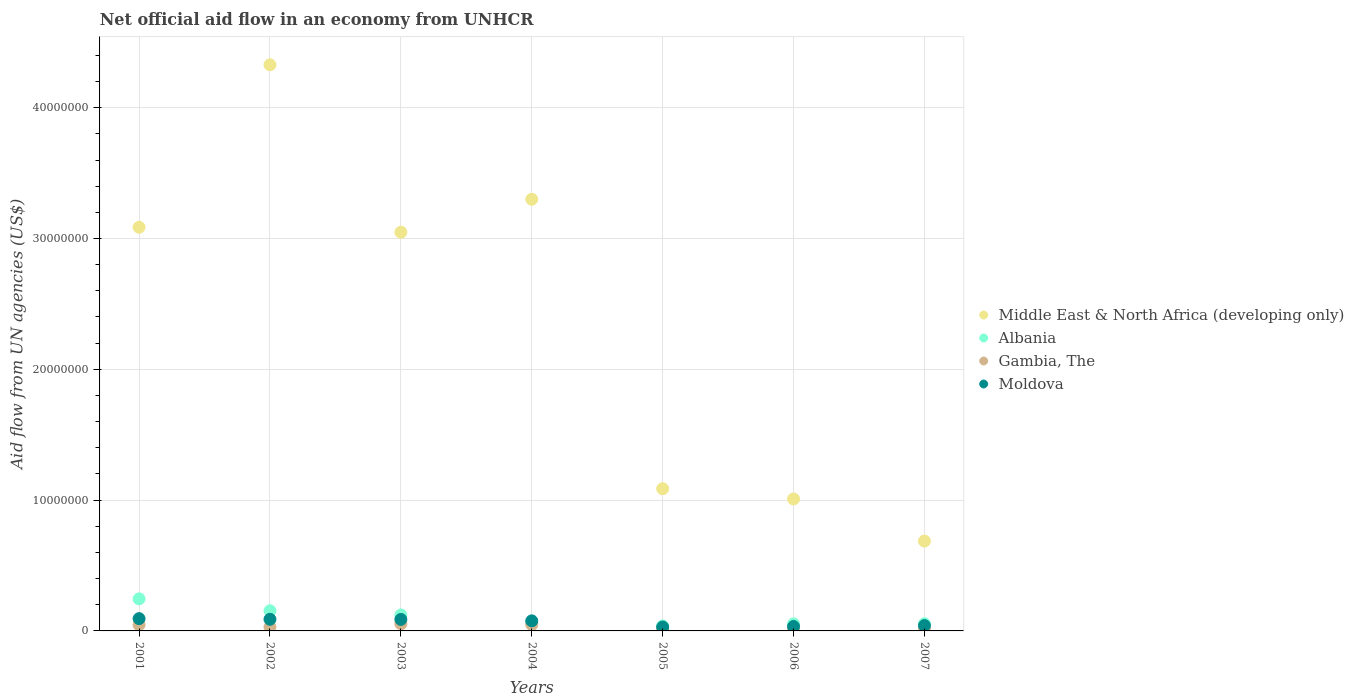How many different coloured dotlines are there?
Your response must be concise. 4. Is the number of dotlines equal to the number of legend labels?
Ensure brevity in your answer.  Yes. Across all years, what is the maximum net official aid flow in Albania?
Your answer should be very brief. 2.45e+06. Across all years, what is the minimum net official aid flow in Moldova?
Your answer should be compact. 3.00e+05. In which year was the net official aid flow in Albania maximum?
Your answer should be very brief. 2001. What is the total net official aid flow in Middle East & North Africa (developing only) in the graph?
Your response must be concise. 1.65e+08. What is the difference between the net official aid flow in Albania in 2006 and that in 2007?
Your response must be concise. -10000. What is the difference between the net official aid flow in Gambia, The in 2005 and the net official aid flow in Middle East & North Africa (developing only) in 2007?
Your answer should be compact. -6.69e+06. What is the average net official aid flow in Middle East & North Africa (developing only) per year?
Give a very brief answer. 2.36e+07. In how many years, is the net official aid flow in Gambia, The greater than 14000000 US$?
Your answer should be compact. 0. What is the ratio of the net official aid flow in Moldova in 2005 to that in 2007?
Your answer should be compact. 0.73. Is the difference between the net official aid flow in Albania in 2003 and 2004 greater than the difference between the net official aid flow in Gambia, The in 2003 and 2004?
Keep it short and to the point. Yes. What is the difference between the highest and the second highest net official aid flow in Gambia, The?
Provide a succinct answer. 6.00e+04. What is the difference between the highest and the lowest net official aid flow in Albania?
Your answer should be very brief. 2.07e+06. In how many years, is the net official aid flow in Albania greater than the average net official aid flow in Albania taken over all years?
Make the answer very short. 3. Is it the case that in every year, the sum of the net official aid flow in Gambia, The and net official aid flow in Moldova  is greater than the net official aid flow in Middle East & North Africa (developing only)?
Offer a very short reply. No. Does the net official aid flow in Middle East & North Africa (developing only) monotonically increase over the years?
Keep it short and to the point. No. Is the net official aid flow in Albania strictly less than the net official aid flow in Gambia, The over the years?
Offer a terse response. No. How many dotlines are there?
Your answer should be compact. 4. How many years are there in the graph?
Give a very brief answer. 7. What is the difference between two consecutive major ticks on the Y-axis?
Offer a terse response. 1.00e+07. Are the values on the major ticks of Y-axis written in scientific E-notation?
Ensure brevity in your answer.  No. Does the graph contain grids?
Ensure brevity in your answer.  Yes. How many legend labels are there?
Your response must be concise. 4. How are the legend labels stacked?
Your response must be concise. Vertical. What is the title of the graph?
Make the answer very short. Net official aid flow in an economy from UNHCR. What is the label or title of the Y-axis?
Your response must be concise. Aid flow from UN agencies (US$). What is the Aid flow from UN agencies (US$) of Middle East & North Africa (developing only) in 2001?
Your answer should be compact. 3.09e+07. What is the Aid flow from UN agencies (US$) in Albania in 2001?
Give a very brief answer. 2.45e+06. What is the Aid flow from UN agencies (US$) in Moldova in 2001?
Your answer should be very brief. 9.40e+05. What is the Aid flow from UN agencies (US$) of Middle East & North Africa (developing only) in 2002?
Offer a terse response. 4.33e+07. What is the Aid flow from UN agencies (US$) in Albania in 2002?
Your response must be concise. 1.54e+06. What is the Aid flow from UN agencies (US$) of Gambia, The in 2002?
Offer a very short reply. 3.00e+05. What is the Aid flow from UN agencies (US$) in Moldova in 2002?
Provide a short and direct response. 8.90e+05. What is the Aid flow from UN agencies (US$) in Middle East & North Africa (developing only) in 2003?
Your answer should be compact. 3.05e+07. What is the Aid flow from UN agencies (US$) of Albania in 2003?
Your answer should be compact. 1.22e+06. What is the Aid flow from UN agencies (US$) in Gambia, The in 2003?
Ensure brevity in your answer.  5.40e+05. What is the Aid flow from UN agencies (US$) in Moldova in 2003?
Provide a short and direct response. 8.80e+05. What is the Aid flow from UN agencies (US$) of Middle East & North Africa (developing only) in 2004?
Give a very brief answer. 3.30e+07. What is the Aid flow from UN agencies (US$) of Albania in 2004?
Ensure brevity in your answer.  6.20e+05. What is the Aid flow from UN agencies (US$) of Moldova in 2004?
Make the answer very short. 7.70e+05. What is the Aid flow from UN agencies (US$) in Middle East & North Africa (developing only) in 2005?
Your response must be concise. 1.09e+07. What is the Aid flow from UN agencies (US$) of Albania in 2005?
Offer a very short reply. 3.80e+05. What is the Aid flow from UN agencies (US$) in Gambia, The in 2005?
Offer a terse response. 1.80e+05. What is the Aid flow from UN agencies (US$) in Middle East & North Africa (developing only) in 2006?
Your answer should be compact. 1.01e+07. What is the Aid flow from UN agencies (US$) of Albania in 2006?
Provide a succinct answer. 5.40e+05. What is the Aid flow from UN agencies (US$) of Middle East & North Africa (developing only) in 2007?
Your answer should be compact. 6.87e+06. What is the Aid flow from UN agencies (US$) in Albania in 2007?
Make the answer very short. 5.50e+05. What is the Aid flow from UN agencies (US$) of Gambia, The in 2007?
Ensure brevity in your answer.  1.20e+05. Across all years, what is the maximum Aid flow from UN agencies (US$) of Middle East & North Africa (developing only)?
Offer a very short reply. 4.33e+07. Across all years, what is the maximum Aid flow from UN agencies (US$) in Albania?
Keep it short and to the point. 2.45e+06. Across all years, what is the maximum Aid flow from UN agencies (US$) of Gambia, The?
Keep it short and to the point. 5.40e+05. Across all years, what is the maximum Aid flow from UN agencies (US$) of Moldova?
Your answer should be compact. 9.40e+05. Across all years, what is the minimum Aid flow from UN agencies (US$) in Middle East & North Africa (developing only)?
Offer a very short reply. 6.87e+06. What is the total Aid flow from UN agencies (US$) of Middle East & North Africa (developing only) in the graph?
Keep it short and to the point. 1.65e+08. What is the total Aid flow from UN agencies (US$) in Albania in the graph?
Offer a terse response. 7.30e+06. What is the total Aid flow from UN agencies (US$) in Gambia, The in the graph?
Your response must be concise. 2.20e+06. What is the total Aid flow from UN agencies (US$) of Moldova in the graph?
Your answer should be very brief. 4.53e+06. What is the difference between the Aid flow from UN agencies (US$) of Middle East & North Africa (developing only) in 2001 and that in 2002?
Your answer should be compact. -1.24e+07. What is the difference between the Aid flow from UN agencies (US$) in Albania in 2001 and that in 2002?
Your answer should be very brief. 9.10e+05. What is the difference between the Aid flow from UN agencies (US$) in Gambia, The in 2001 and that in 2002?
Offer a terse response. 1.70e+05. What is the difference between the Aid flow from UN agencies (US$) of Middle East & North Africa (developing only) in 2001 and that in 2003?
Offer a terse response. 3.80e+05. What is the difference between the Aid flow from UN agencies (US$) of Albania in 2001 and that in 2003?
Ensure brevity in your answer.  1.23e+06. What is the difference between the Aid flow from UN agencies (US$) in Moldova in 2001 and that in 2003?
Offer a terse response. 6.00e+04. What is the difference between the Aid flow from UN agencies (US$) of Middle East & North Africa (developing only) in 2001 and that in 2004?
Your answer should be compact. -2.14e+06. What is the difference between the Aid flow from UN agencies (US$) in Albania in 2001 and that in 2004?
Keep it short and to the point. 1.83e+06. What is the difference between the Aid flow from UN agencies (US$) in Middle East & North Africa (developing only) in 2001 and that in 2005?
Your response must be concise. 2.00e+07. What is the difference between the Aid flow from UN agencies (US$) in Albania in 2001 and that in 2005?
Provide a short and direct response. 2.07e+06. What is the difference between the Aid flow from UN agencies (US$) in Gambia, The in 2001 and that in 2005?
Provide a short and direct response. 2.90e+05. What is the difference between the Aid flow from UN agencies (US$) of Moldova in 2001 and that in 2005?
Provide a short and direct response. 6.40e+05. What is the difference between the Aid flow from UN agencies (US$) of Middle East & North Africa (developing only) in 2001 and that in 2006?
Make the answer very short. 2.08e+07. What is the difference between the Aid flow from UN agencies (US$) of Albania in 2001 and that in 2006?
Provide a succinct answer. 1.91e+06. What is the difference between the Aid flow from UN agencies (US$) in Gambia, The in 2001 and that in 2006?
Make the answer very short. 3.60e+05. What is the difference between the Aid flow from UN agencies (US$) of Moldova in 2001 and that in 2006?
Your answer should be compact. 6.00e+05. What is the difference between the Aid flow from UN agencies (US$) in Middle East & North Africa (developing only) in 2001 and that in 2007?
Offer a very short reply. 2.40e+07. What is the difference between the Aid flow from UN agencies (US$) of Albania in 2001 and that in 2007?
Keep it short and to the point. 1.90e+06. What is the difference between the Aid flow from UN agencies (US$) in Moldova in 2001 and that in 2007?
Your answer should be very brief. 5.30e+05. What is the difference between the Aid flow from UN agencies (US$) in Middle East & North Africa (developing only) in 2002 and that in 2003?
Your response must be concise. 1.28e+07. What is the difference between the Aid flow from UN agencies (US$) in Middle East & North Africa (developing only) in 2002 and that in 2004?
Offer a terse response. 1.03e+07. What is the difference between the Aid flow from UN agencies (US$) of Albania in 2002 and that in 2004?
Your response must be concise. 9.20e+05. What is the difference between the Aid flow from UN agencies (US$) in Middle East & North Africa (developing only) in 2002 and that in 2005?
Ensure brevity in your answer.  3.24e+07. What is the difference between the Aid flow from UN agencies (US$) in Albania in 2002 and that in 2005?
Offer a very short reply. 1.16e+06. What is the difference between the Aid flow from UN agencies (US$) in Moldova in 2002 and that in 2005?
Your response must be concise. 5.90e+05. What is the difference between the Aid flow from UN agencies (US$) in Middle East & North Africa (developing only) in 2002 and that in 2006?
Make the answer very short. 3.32e+07. What is the difference between the Aid flow from UN agencies (US$) in Gambia, The in 2002 and that in 2006?
Provide a succinct answer. 1.90e+05. What is the difference between the Aid flow from UN agencies (US$) of Middle East & North Africa (developing only) in 2002 and that in 2007?
Your answer should be very brief. 3.64e+07. What is the difference between the Aid flow from UN agencies (US$) of Albania in 2002 and that in 2007?
Your response must be concise. 9.90e+05. What is the difference between the Aid flow from UN agencies (US$) in Gambia, The in 2002 and that in 2007?
Your answer should be very brief. 1.80e+05. What is the difference between the Aid flow from UN agencies (US$) in Middle East & North Africa (developing only) in 2003 and that in 2004?
Keep it short and to the point. -2.52e+06. What is the difference between the Aid flow from UN agencies (US$) of Gambia, The in 2003 and that in 2004?
Provide a succinct answer. 6.00e+04. What is the difference between the Aid flow from UN agencies (US$) in Middle East & North Africa (developing only) in 2003 and that in 2005?
Offer a very short reply. 1.96e+07. What is the difference between the Aid flow from UN agencies (US$) in Albania in 2003 and that in 2005?
Give a very brief answer. 8.40e+05. What is the difference between the Aid flow from UN agencies (US$) in Gambia, The in 2003 and that in 2005?
Offer a terse response. 3.60e+05. What is the difference between the Aid flow from UN agencies (US$) in Moldova in 2003 and that in 2005?
Offer a terse response. 5.80e+05. What is the difference between the Aid flow from UN agencies (US$) of Middle East & North Africa (developing only) in 2003 and that in 2006?
Ensure brevity in your answer.  2.04e+07. What is the difference between the Aid flow from UN agencies (US$) in Albania in 2003 and that in 2006?
Provide a short and direct response. 6.80e+05. What is the difference between the Aid flow from UN agencies (US$) in Moldova in 2003 and that in 2006?
Keep it short and to the point. 5.40e+05. What is the difference between the Aid flow from UN agencies (US$) in Middle East & North Africa (developing only) in 2003 and that in 2007?
Your answer should be very brief. 2.36e+07. What is the difference between the Aid flow from UN agencies (US$) in Albania in 2003 and that in 2007?
Your response must be concise. 6.70e+05. What is the difference between the Aid flow from UN agencies (US$) of Middle East & North Africa (developing only) in 2004 and that in 2005?
Give a very brief answer. 2.21e+07. What is the difference between the Aid flow from UN agencies (US$) in Gambia, The in 2004 and that in 2005?
Offer a very short reply. 3.00e+05. What is the difference between the Aid flow from UN agencies (US$) of Middle East & North Africa (developing only) in 2004 and that in 2006?
Offer a terse response. 2.29e+07. What is the difference between the Aid flow from UN agencies (US$) of Gambia, The in 2004 and that in 2006?
Your answer should be very brief. 3.70e+05. What is the difference between the Aid flow from UN agencies (US$) of Middle East & North Africa (developing only) in 2004 and that in 2007?
Make the answer very short. 2.61e+07. What is the difference between the Aid flow from UN agencies (US$) in Albania in 2004 and that in 2007?
Make the answer very short. 7.00e+04. What is the difference between the Aid flow from UN agencies (US$) in Moldova in 2004 and that in 2007?
Your response must be concise. 3.60e+05. What is the difference between the Aid flow from UN agencies (US$) in Middle East & North Africa (developing only) in 2005 and that in 2006?
Offer a very short reply. 7.80e+05. What is the difference between the Aid flow from UN agencies (US$) in Albania in 2005 and that in 2006?
Your response must be concise. -1.60e+05. What is the difference between the Aid flow from UN agencies (US$) in Gambia, The in 2005 and that in 2006?
Make the answer very short. 7.00e+04. What is the difference between the Aid flow from UN agencies (US$) in Moldova in 2005 and that in 2006?
Your answer should be very brief. -4.00e+04. What is the difference between the Aid flow from UN agencies (US$) in Middle East & North Africa (developing only) in 2005 and that in 2007?
Offer a terse response. 4.00e+06. What is the difference between the Aid flow from UN agencies (US$) in Albania in 2005 and that in 2007?
Give a very brief answer. -1.70e+05. What is the difference between the Aid flow from UN agencies (US$) of Middle East & North Africa (developing only) in 2006 and that in 2007?
Your answer should be very brief. 3.22e+06. What is the difference between the Aid flow from UN agencies (US$) in Albania in 2006 and that in 2007?
Keep it short and to the point. -10000. What is the difference between the Aid flow from UN agencies (US$) of Middle East & North Africa (developing only) in 2001 and the Aid flow from UN agencies (US$) of Albania in 2002?
Provide a short and direct response. 2.93e+07. What is the difference between the Aid flow from UN agencies (US$) of Middle East & North Africa (developing only) in 2001 and the Aid flow from UN agencies (US$) of Gambia, The in 2002?
Provide a short and direct response. 3.06e+07. What is the difference between the Aid flow from UN agencies (US$) in Middle East & North Africa (developing only) in 2001 and the Aid flow from UN agencies (US$) in Moldova in 2002?
Offer a very short reply. 3.00e+07. What is the difference between the Aid flow from UN agencies (US$) in Albania in 2001 and the Aid flow from UN agencies (US$) in Gambia, The in 2002?
Provide a succinct answer. 2.15e+06. What is the difference between the Aid flow from UN agencies (US$) of Albania in 2001 and the Aid flow from UN agencies (US$) of Moldova in 2002?
Make the answer very short. 1.56e+06. What is the difference between the Aid flow from UN agencies (US$) of Gambia, The in 2001 and the Aid flow from UN agencies (US$) of Moldova in 2002?
Your answer should be very brief. -4.20e+05. What is the difference between the Aid flow from UN agencies (US$) of Middle East & North Africa (developing only) in 2001 and the Aid flow from UN agencies (US$) of Albania in 2003?
Your response must be concise. 2.96e+07. What is the difference between the Aid flow from UN agencies (US$) of Middle East & North Africa (developing only) in 2001 and the Aid flow from UN agencies (US$) of Gambia, The in 2003?
Provide a short and direct response. 3.03e+07. What is the difference between the Aid flow from UN agencies (US$) of Middle East & North Africa (developing only) in 2001 and the Aid flow from UN agencies (US$) of Moldova in 2003?
Your answer should be very brief. 3.00e+07. What is the difference between the Aid flow from UN agencies (US$) in Albania in 2001 and the Aid flow from UN agencies (US$) in Gambia, The in 2003?
Make the answer very short. 1.91e+06. What is the difference between the Aid flow from UN agencies (US$) in Albania in 2001 and the Aid flow from UN agencies (US$) in Moldova in 2003?
Offer a terse response. 1.57e+06. What is the difference between the Aid flow from UN agencies (US$) of Gambia, The in 2001 and the Aid flow from UN agencies (US$) of Moldova in 2003?
Ensure brevity in your answer.  -4.10e+05. What is the difference between the Aid flow from UN agencies (US$) of Middle East & North Africa (developing only) in 2001 and the Aid flow from UN agencies (US$) of Albania in 2004?
Ensure brevity in your answer.  3.02e+07. What is the difference between the Aid flow from UN agencies (US$) of Middle East & North Africa (developing only) in 2001 and the Aid flow from UN agencies (US$) of Gambia, The in 2004?
Provide a short and direct response. 3.04e+07. What is the difference between the Aid flow from UN agencies (US$) of Middle East & North Africa (developing only) in 2001 and the Aid flow from UN agencies (US$) of Moldova in 2004?
Offer a terse response. 3.01e+07. What is the difference between the Aid flow from UN agencies (US$) of Albania in 2001 and the Aid flow from UN agencies (US$) of Gambia, The in 2004?
Make the answer very short. 1.97e+06. What is the difference between the Aid flow from UN agencies (US$) in Albania in 2001 and the Aid flow from UN agencies (US$) in Moldova in 2004?
Your answer should be compact. 1.68e+06. What is the difference between the Aid flow from UN agencies (US$) in Gambia, The in 2001 and the Aid flow from UN agencies (US$) in Moldova in 2004?
Your response must be concise. -3.00e+05. What is the difference between the Aid flow from UN agencies (US$) of Middle East & North Africa (developing only) in 2001 and the Aid flow from UN agencies (US$) of Albania in 2005?
Offer a very short reply. 3.05e+07. What is the difference between the Aid flow from UN agencies (US$) in Middle East & North Africa (developing only) in 2001 and the Aid flow from UN agencies (US$) in Gambia, The in 2005?
Keep it short and to the point. 3.07e+07. What is the difference between the Aid flow from UN agencies (US$) of Middle East & North Africa (developing only) in 2001 and the Aid flow from UN agencies (US$) of Moldova in 2005?
Offer a terse response. 3.06e+07. What is the difference between the Aid flow from UN agencies (US$) in Albania in 2001 and the Aid flow from UN agencies (US$) in Gambia, The in 2005?
Keep it short and to the point. 2.27e+06. What is the difference between the Aid flow from UN agencies (US$) of Albania in 2001 and the Aid flow from UN agencies (US$) of Moldova in 2005?
Your answer should be compact. 2.15e+06. What is the difference between the Aid flow from UN agencies (US$) in Middle East & North Africa (developing only) in 2001 and the Aid flow from UN agencies (US$) in Albania in 2006?
Offer a very short reply. 3.03e+07. What is the difference between the Aid flow from UN agencies (US$) in Middle East & North Africa (developing only) in 2001 and the Aid flow from UN agencies (US$) in Gambia, The in 2006?
Provide a succinct answer. 3.08e+07. What is the difference between the Aid flow from UN agencies (US$) in Middle East & North Africa (developing only) in 2001 and the Aid flow from UN agencies (US$) in Moldova in 2006?
Your answer should be very brief. 3.05e+07. What is the difference between the Aid flow from UN agencies (US$) of Albania in 2001 and the Aid flow from UN agencies (US$) of Gambia, The in 2006?
Make the answer very short. 2.34e+06. What is the difference between the Aid flow from UN agencies (US$) of Albania in 2001 and the Aid flow from UN agencies (US$) of Moldova in 2006?
Your response must be concise. 2.11e+06. What is the difference between the Aid flow from UN agencies (US$) in Middle East & North Africa (developing only) in 2001 and the Aid flow from UN agencies (US$) in Albania in 2007?
Give a very brief answer. 3.03e+07. What is the difference between the Aid flow from UN agencies (US$) of Middle East & North Africa (developing only) in 2001 and the Aid flow from UN agencies (US$) of Gambia, The in 2007?
Offer a terse response. 3.07e+07. What is the difference between the Aid flow from UN agencies (US$) in Middle East & North Africa (developing only) in 2001 and the Aid flow from UN agencies (US$) in Moldova in 2007?
Offer a terse response. 3.04e+07. What is the difference between the Aid flow from UN agencies (US$) in Albania in 2001 and the Aid flow from UN agencies (US$) in Gambia, The in 2007?
Offer a very short reply. 2.33e+06. What is the difference between the Aid flow from UN agencies (US$) of Albania in 2001 and the Aid flow from UN agencies (US$) of Moldova in 2007?
Make the answer very short. 2.04e+06. What is the difference between the Aid flow from UN agencies (US$) in Gambia, The in 2001 and the Aid flow from UN agencies (US$) in Moldova in 2007?
Keep it short and to the point. 6.00e+04. What is the difference between the Aid flow from UN agencies (US$) in Middle East & North Africa (developing only) in 2002 and the Aid flow from UN agencies (US$) in Albania in 2003?
Offer a terse response. 4.21e+07. What is the difference between the Aid flow from UN agencies (US$) in Middle East & North Africa (developing only) in 2002 and the Aid flow from UN agencies (US$) in Gambia, The in 2003?
Your answer should be compact. 4.27e+07. What is the difference between the Aid flow from UN agencies (US$) of Middle East & North Africa (developing only) in 2002 and the Aid flow from UN agencies (US$) of Moldova in 2003?
Ensure brevity in your answer.  4.24e+07. What is the difference between the Aid flow from UN agencies (US$) in Albania in 2002 and the Aid flow from UN agencies (US$) in Gambia, The in 2003?
Your answer should be compact. 1.00e+06. What is the difference between the Aid flow from UN agencies (US$) of Gambia, The in 2002 and the Aid flow from UN agencies (US$) of Moldova in 2003?
Offer a terse response. -5.80e+05. What is the difference between the Aid flow from UN agencies (US$) of Middle East & North Africa (developing only) in 2002 and the Aid flow from UN agencies (US$) of Albania in 2004?
Make the answer very short. 4.27e+07. What is the difference between the Aid flow from UN agencies (US$) in Middle East & North Africa (developing only) in 2002 and the Aid flow from UN agencies (US$) in Gambia, The in 2004?
Provide a succinct answer. 4.28e+07. What is the difference between the Aid flow from UN agencies (US$) of Middle East & North Africa (developing only) in 2002 and the Aid flow from UN agencies (US$) of Moldova in 2004?
Keep it short and to the point. 4.25e+07. What is the difference between the Aid flow from UN agencies (US$) of Albania in 2002 and the Aid flow from UN agencies (US$) of Gambia, The in 2004?
Your answer should be very brief. 1.06e+06. What is the difference between the Aid flow from UN agencies (US$) in Albania in 2002 and the Aid flow from UN agencies (US$) in Moldova in 2004?
Ensure brevity in your answer.  7.70e+05. What is the difference between the Aid flow from UN agencies (US$) of Gambia, The in 2002 and the Aid flow from UN agencies (US$) of Moldova in 2004?
Make the answer very short. -4.70e+05. What is the difference between the Aid flow from UN agencies (US$) of Middle East & North Africa (developing only) in 2002 and the Aid flow from UN agencies (US$) of Albania in 2005?
Your answer should be compact. 4.29e+07. What is the difference between the Aid flow from UN agencies (US$) of Middle East & North Africa (developing only) in 2002 and the Aid flow from UN agencies (US$) of Gambia, The in 2005?
Ensure brevity in your answer.  4.31e+07. What is the difference between the Aid flow from UN agencies (US$) of Middle East & North Africa (developing only) in 2002 and the Aid flow from UN agencies (US$) of Moldova in 2005?
Provide a succinct answer. 4.30e+07. What is the difference between the Aid flow from UN agencies (US$) of Albania in 2002 and the Aid flow from UN agencies (US$) of Gambia, The in 2005?
Your answer should be very brief. 1.36e+06. What is the difference between the Aid flow from UN agencies (US$) in Albania in 2002 and the Aid flow from UN agencies (US$) in Moldova in 2005?
Give a very brief answer. 1.24e+06. What is the difference between the Aid flow from UN agencies (US$) in Middle East & North Africa (developing only) in 2002 and the Aid flow from UN agencies (US$) in Albania in 2006?
Give a very brief answer. 4.27e+07. What is the difference between the Aid flow from UN agencies (US$) of Middle East & North Africa (developing only) in 2002 and the Aid flow from UN agencies (US$) of Gambia, The in 2006?
Give a very brief answer. 4.32e+07. What is the difference between the Aid flow from UN agencies (US$) of Middle East & North Africa (developing only) in 2002 and the Aid flow from UN agencies (US$) of Moldova in 2006?
Your answer should be compact. 4.29e+07. What is the difference between the Aid flow from UN agencies (US$) of Albania in 2002 and the Aid flow from UN agencies (US$) of Gambia, The in 2006?
Make the answer very short. 1.43e+06. What is the difference between the Aid flow from UN agencies (US$) of Albania in 2002 and the Aid flow from UN agencies (US$) of Moldova in 2006?
Your response must be concise. 1.20e+06. What is the difference between the Aid flow from UN agencies (US$) of Gambia, The in 2002 and the Aid flow from UN agencies (US$) of Moldova in 2006?
Ensure brevity in your answer.  -4.00e+04. What is the difference between the Aid flow from UN agencies (US$) in Middle East & North Africa (developing only) in 2002 and the Aid flow from UN agencies (US$) in Albania in 2007?
Your response must be concise. 4.27e+07. What is the difference between the Aid flow from UN agencies (US$) in Middle East & North Africa (developing only) in 2002 and the Aid flow from UN agencies (US$) in Gambia, The in 2007?
Make the answer very short. 4.32e+07. What is the difference between the Aid flow from UN agencies (US$) in Middle East & North Africa (developing only) in 2002 and the Aid flow from UN agencies (US$) in Moldova in 2007?
Offer a very short reply. 4.29e+07. What is the difference between the Aid flow from UN agencies (US$) in Albania in 2002 and the Aid flow from UN agencies (US$) in Gambia, The in 2007?
Keep it short and to the point. 1.42e+06. What is the difference between the Aid flow from UN agencies (US$) of Albania in 2002 and the Aid flow from UN agencies (US$) of Moldova in 2007?
Make the answer very short. 1.13e+06. What is the difference between the Aid flow from UN agencies (US$) in Middle East & North Africa (developing only) in 2003 and the Aid flow from UN agencies (US$) in Albania in 2004?
Offer a very short reply. 2.99e+07. What is the difference between the Aid flow from UN agencies (US$) in Middle East & North Africa (developing only) in 2003 and the Aid flow from UN agencies (US$) in Gambia, The in 2004?
Your response must be concise. 3.00e+07. What is the difference between the Aid flow from UN agencies (US$) in Middle East & North Africa (developing only) in 2003 and the Aid flow from UN agencies (US$) in Moldova in 2004?
Your answer should be very brief. 2.97e+07. What is the difference between the Aid flow from UN agencies (US$) in Albania in 2003 and the Aid flow from UN agencies (US$) in Gambia, The in 2004?
Your response must be concise. 7.40e+05. What is the difference between the Aid flow from UN agencies (US$) in Albania in 2003 and the Aid flow from UN agencies (US$) in Moldova in 2004?
Offer a very short reply. 4.50e+05. What is the difference between the Aid flow from UN agencies (US$) in Middle East & North Africa (developing only) in 2003 and the Aid flow from UN agencies (US$) in Albania in 2005?
Keep it short and to the point. 3.01e+07. What is the difference between the Aid flow from UN agencies (US$) of Middle East & North Africa (developing only) in 2003 and the Aid flow from UN agencies (US$) of Gambia, The in 2005?
Provide a short and direct response. 3.03e+07. What is the difference between the Aid flow from UN agencies (US$) in Middle East & North Africa (developing only) in 2003 and the Aid flow from UN agencies (US$) in Moldova in 2005?
Give a very brief answer. 3.02e+07. What is the difference between the Aid flow from UN agencies (US$) of Albania in 2003 and the Aid flow from UN agencies (US$) of Gambia, The in 2005?
Provide a short and direct response. 1.04e+06. What is the difference between the Aid flow from UN agencies (US$) in Albania in 2003 and the Aid flow from UN agencies (US$) in Moldova in 2005?
Offer a very short reply. 9.20e+05. What is the difference between the Aid flow from UN agencies (US$) of Middle East & North Africa (developing only) in 2003 and the Aid flow from UN agencies (US$) of Albania in 2006?
Provide a succinct answer. 2.99e+07. What is the difference between the Aid flow from UN agencies (US$) of Middle East & North Africa (developing only) in 2003 and the Aid flow from UN agencies (US$) of Gambia, The in 2006?
Keep it short and to the point. 3.04e+07. What is the difference between the Aid flow from UN agencies (US$) of Middle East & North Africa (developing only) in 2003 and the Aid flow from UN agencies (US$) of Moldova in 2006?
Your answer should be compact. 3.01e+07. What is the difference between the Aid flow from UN agencies (US$) in Albania in 2003 and the Aid flow from UN agencies (US$) in Gambia, The in 2006?
Keep it short and to the point. 1.11e+06. What is the difference between the Aid flow from UN agencies (US$) of Albania in 2003 and the Aid flow from UN agencies (US$) of Moldova in 2006?
Make the answer very short. 8.80e+05. What is the difference between the Aid flow from UN agencies (US$) in Gambia, The in 2003 and the Aid flow from UN agencies (US$) in Moldova in 2006?
Your response must be concise. 2.00e+05. What is the difference between the Aid flow from UN agencies (US$) of Middle East & North Africa (developing only) in 2003 and the Aid flow from UN agencies (US$) of Albania in 2007?
Ensure brevity in your answer.  2.99e+07. What is the difference between the Aid flow from UN agencies (US$) of Middle East & North Africa (developing only) in 2003 and the Aid flow from UN agencies (US$) of Gambia, The in 2007?
Provide a succinct answer. 3.04e+07. What is the difference between the Aid flow from UN agencies (US$) of Middle East & North Africa (developing only) in 2003 and the Aid flow from UN agencies (US$) of Moldova in 2007?
Offer a very short reply. 3.01e+07. What is the difference between the Aid flow from UN agencies (US$) in Albania in 2003 and the Aid flow from UN agencies (US$) in Gambia, The in 2007?
Offer a terse response. 1.10e+06. What is the difference between the Aid flow from UN agencies (US$) in Albania in 2003 and the Aid flow from UN agencies (US$) in Moldova in 2007?
Your response must be concise. 8.10e+05. What is the difference between the Aid flow from UN agencies (US$) in Middle East & North Africa (developing only) in 2004 and the Aid flow from UN agencies (US$) in Albania in 2005?
Make the answer very short. 3.26e+07. What is the difference between the Aid flow from UN agencies (US$) in Middle East & North Africa (developing only) in 2004 and the Aid flow from UN agencies (US$) in Gambia, The in 2005?
Make the answer very short. 3.28e+07. What is the difference between the Aid flow from UN agencies (US$) of Middle East & North Africa (developing only) in 2004 and the Aid flow from UN agencies (US$) of Moldova in 2005?
Offer a terse response. 3.27e+07. What is the difference between the Aid flow from UN agencies (US$) of Albania in 2004 and the Aid flow from UN agencies (US$) of Moldova in 2005?
Provide a succinct answer. 3.20e+05. What is the difference between the Aid flow from UN agencies (US$) of Gambia, The in 2004 and the Aid flow from UN agencies (US$) of Moldova in 2005?
Provide a succinct answer. 1.80e+05. What is the difference between the Aid flow from UN agencies (US$) of Middle East & North Africa (developing only) in 2004 and the Aid flow from UN agencies (US$) of Albania in 2006?
Your response must be concise. 3.25e+07. What is the difference between the Aid flow from UN agencies (US$) in Middle East & North Africa (developing only) in 2004 and the Aid flow from UN agencies (US$) in Gambia, The in 2006?
Make the answer very short. 3.29e+07. What is the difference between the Aid flow from UN agencies (US$) of Middle East & North Africa (developing only) in 2004 and the Aid flow from UN agencies (US$) of Moldova in 2006?
Your answer should be very brief. 3.27e+07. What is the difference between the Aid flow from UN agencies (US$) of Albania in 2004 and the Aid flow from UN agencies (US$) of Gambia, The in 2006?
Provide a succinct answer. 5.10e+05. What is the difference between the Aid flow from UN agencies (US$) in Albania in 2004 and the Aid flow from UN agencies (US$) in Moldova in 2006?
Give a very brief answer. 2.80e+05. What is the difference between the Aid flow from UN agencies (US$) of Middle East & North Africa (developing only) in 2004 and the Aid flow from UN agencies (US$) of Albania in 2007?
Provide a short and direct response. 3.24e+07. What is the difference between the Aid flow from UN agencies (US$) of Middle East & North Africa (developing only) in 2004 and the Aid flow from UN agencies (US$) of Gambia, The in 2007?
Offer a terse response. 3.29e+07. What is the difference between the Aid flow from UN agencies (US$) of Middle East & North Africa (developing only) in 2004 and the Aid flow from UN agencies (US$) of Moldova in 2007?
Give a very brief answer. 3.26e+07. What is the difference between the Aid flow from UN agencies (US$) of Albania in 2004 and the Aid flow from UN agencies (US$) of Gambia, The in 2007?
Ensure brevity in your answer.  5.00e+05. What is the difference between the Aid flow from UN agencies (US$) of Albania in 2004 and the Aid flow from UN agencies (US$) of Moldova in 2007?
Offer a terse response. 2.10e+05. What is the difference between the Aid flow from UN agencies (US$) of Middle East & North Africa (developing only) in 2005 and the Aid flow from UN agencies (US$) of Albania in 2006?
Offer a very short reply. 1.03e+07. What is the difference between the Aid flow from UN agencies (US$) in Middle East & North Africa (developing only) in 2005 and the Aid flow from UN agencies (US$) in Gambia, The in 2006?
Offer a terse response. 1.08e+07. What is the difference between the Aid flow from UN agencies (US$) of Middle East & North Africa (developing only) in 2005 and the Aid flow from UN agencies (US$) of Moldova in 2006?
Your response must be concise. 1.05e+07. What is the difference between the Aid flow from UN agencies (US$) of Middle East & North Africa (developing only) in 2005 and the Aid flow from UN agencies (US$) of Albania in 2007?
Give a very brief answer. 1.03e+07. What is the difference between the Aid flow from UN agencies (US$) in Middle East & North Africa (developing only) in 2005 and the Aid flow from UN agencies (US$) in Gambia, The in 2007?
Provide a succinct answer. 1.08e+07. What is the difference between the Aid flow from UN agencies (US$) in Middle East & North Africa (developing only) in 2005 and the Aid flow from UN agencies (US$) in Moldova in 2007?
Make the answer very short. 1.05e+07. What is the difference between the Aid flow from UN agencies (US$) in Albania in 2005 and the Aid flow from UN agencies (US$) in Gambia, The in 2007?
Your response must be concise. 2.60e+05. What is the difference between the Aid flow from UN agencies (US$) of Albania in 2005 and the Aid flow from UN agencies (US$) of Moldova in 2007?
Offer a very short reply. -3.00e+04. What is the difference between the Aid flow from UN agencies (US$) in Gambia, The in 2005 and the Aid flow from UN agencies (US$) in Moldova in 2007?
Make the answer very short. -2.30e+05. What is the difference between the Aid flow from UN agencies (US$) in Middle East & North Africa (developing only) in 2006 and the Aid flow from UN agencies (US$) in Albania in 2007?
Your answer should be compact. 9.54e+06. What is the difference between the Aid flow from UN agencies (US$) in Middle East & North Africa (developing only) in 2006 and the Aid flow from UN agencies (US$) in Gambia, The in 2007?
Ensure brevity in your answer.  9.97e+06. What is the difference between the Aid flow from UN agencies (US$) of Middle East & North Africa (developing only) in 2006 and the Aid flow from UN agencies (US$) of Moldova in 2007?
Your answer should be very brief. 9.68e+06. What is the difference between the Aid flow from UN agencies (US$) in Albania in 2006 and the Aid flow from UN agencies (US$) in Gambia, The in 2007?
Offer a very short reply. 4.20e+05. What is the average Aid flow from UN agencies (US$) in Middle East & North Africa (developing only) per year?
Keep it short and to the point. 2.36e+07. What is the average Aid flow from UN agencies (US$) in Albania per year?
Keep it short and to the point. 1.04e+06. What is the average Aid flow from UN agencies (US$) of Gambia, The per year?
Give a very brief answer. 3.14e+05. What is the average Aid flow from UN agencies (US$) of Moldova per year?
Provide a succinct answer. 6.47e+05. In the year 2001, what is the difference between the Aid flow from UN agencies (US$) in Middle East & North Africa (developing only) and Aid flow from UN agencies (US$) in Albania?
Provide a short and direct response. 2.84e+07. In the year 2001, what is the difference between the Aid flow from UN agencies (US$) in Middle East & North Africa (developing only) and Aid flow from UN agencies (US$) in Gambia, The?
Provide a short and direct response. 3.04e+07. In the year 2001, what is the difference between the Aid flow from UN agencies (US$) of Middle East & North Africa (developing only) and Aid flow from UN agencies (US$) of Moldova?
Your answer should be compact. 2.99e+07. In the year 2001, what is the difference between the Aid flow from UN agencies (US$) of Albania and Aid flow from UN agencies (US$) of Gambia, The?
Your answer should be very brief. 1.98e+06. In the year 2001, what is the difference between the Aid flow from UN agencies (US$) in Albania and Aid flow from UN agencies (US$) in Moldova?
Make the answer very short. 1.51e+06. In the year 2001, what is the difference between the Aid flow from UN agencies (US$) in Gambia, The and Aid flow from UN agencies (US$) in Moldova?
Ensure brevity in your answer.  -4.70e+05. In the year 2002, what is the difference between the Aid flow from UN agencies (US$) in Middle East & North Africa (developing only) and Aid flow from UN agencies (US$) in Albania?
Keep it short and to the point. 4.17e+07. In the year 2002, what is the difference between the Aid flow from UN agencies (US$) in Middle East & North Africa (developing only) and Aid flow from UN agencies (US$) in Gambia, The?
Your answer should be compact. 4.30e+07. In the year 2002, what is the difference between the Aid flow from UN agencies (US$) of Middle East & North Africa (developing only) and Aid flow from UN agencies (US$) of Moldova?
Ensure brevity in your answer.  4.24e+07. In the year 2002, what is the difference between the Aid flow from UN agencies (US$) in Albania and Aid flow from UN agencies (US$) in Gambia, The?
Make the answer very short. 1.24e+06. In the year 2002, what is the difference between the Aid flow from UN agencies (US$) of Albania and Aid flow from UN agencies (US$) of Moldova?
Your answer should be very brief. 6.50e+05. In the year 2002, what is the difference between the Aid flow from UN agencies (US$) in Gambia, The and Aid flow from UN agencies (US$) in Moldova?
Your answer should be compact. -5.90e+05. In the year 2003, what is the difference between the Aid flow from UN agencies (US$) of Middle East & North Africa (developing only) and Aid flow from UN agencies (US$) of Albania?
Offer a terse response. 2.93e+07. In the year 2003, what is the difference between the Aid flow from UN agencies (US$) in Middle East & North Africa (developing only) and Aid flow from UN agencies (US$) in Gambia, The?
Offer a terse response. 2.99e+07. In the year 2003, what is the difference between the Aid flow from UN agencies (US$) of Middle East & North Africa (developing only) and Aid flow from UN agencies (US$) of Moldova?
Keep it short and to the point. 2.96e+07. In the year 2003, what is the difference between the Aid flow from UN agencies (US$) in Albania and Aid flow from UN agencies (US$) in Gambia, The?
Provide a succinct answer. 6.80e+05. In the year 2003, what is the difference between the Aid flow from UN agencies (US$) in Gambia, The and Aid flow from UN agencies (US$) in Moldova?
Your answer should be very brief. -3.40e+05. In the year 2004, what is the difference between the Aid flow from UN agencies (US$) in Middle East & North Africa (developing only) and Aid flow from UN agencies (US$) in Albania?
Give a very brief answer. 3.24e+07. In the year 2004, what is the difference between the Aid flow from UN agencies (US$) of Middle East & North Africa (developing only) and Aid flow from UN agencies (US$) of Gambia, The?
Make the answer very short. 3.25e+07. In the year 2004, what is the difference between the Aid flow from UN agencies (US$) of Middle East & North Africa (developing only) and Aid flow from UN agencies (US$) of Moldova?
Give a very brief answer. 3.22e+07. In the year 2004, what is the difference between the Aid flow from UN agencies (US$) in Albania and Aid flow from UN agencies (US$) in Gambia, The?
Ensure brevity in your answer.  1.40e+05. In the year 2004, what is the difference between the Aid flow from UN agencies (US$) of Albania and Aid flow from UN agencies (US$) of Moldova?
Offer a terse response. -1.50e+05. In the year 2005, what is the difference between the Aid flow from UN agencies (US$) of Middle East & North Africa (developing only) and Aid flow from UN agencies (US$) of Albania?
Ensure brevity in your answer.  1.05e+07. In the year 2005, what is the difference between the Aid flow from UN agencies (US$) of Middle East & North Africa (developing only) and Aid flow from UN agencies (US$) of Gambia, The?
Provide a short and direct response. 1.07e+07. In the year 2005, what is the difference between the Aid flow from UN agencies (US$) of Middle East & North Africa (developing only) and Aid flow from UN agencies (US$) of Moldova?
Provide a short and direct response. 1.06e+07. In the year 2005, what is the difference between the Aid flow from UN agencies (US$) in Albania and Aid flow from UN agencies (US$) in Moldova?
Provide a short and direct response. 8.00e+04. In the year 2006, what is the difference between the Aid flow from UN agencies (US$) of Middle East & North Africa (developing only) and Aid flow from UN agencies (US$) of Albania?
Provide a succinct answer. 9.55e+06. In the year 2006, what is the difference between the Aid flow from UN agencies (US$) of Middle East & North Africa (developing only) and Aid flow from UN agencies (US$) of Gambia, The?
Your answer should be very brief. 9.98e+06. In the year 2006, what is the difference between the Aid flow from UN agencies (US$) of Middle East & North Africa (developing only) and Aid flow from UN agencies (US$) of Moldova?
Offer a terse response. 9.75e+06. In the year 2006, what is the difference between the Aid flow from UN agencies (US$) of Albania and Aid flow from UN agencies (US$) of Gambia, The?
Ensure brevity in your answer.  4.30e+05. In the year 2006, what is the difference between the Aid flow from UN agencies (US$) in Gambia, The and Aid flow from UN agencies (US$) in Moldova?
Your response must be concise. -2.30e+05. In the year 2007, what is the difference between the Aid flow from UN agencies (US$) in Middle East & North Africa (developing only) and Aid flow from UN agencies (US$) in Albania?
Your answer should be compact. 6.32e+06. In the year 2007, what is the difference between the Aid flow from UN agencies (US$) of Middle East & North Africa (developing only) and Aid flow from UN agencies (US$) of Gambia, The?
Your answer should be compact. 6.75e+06. In the year 2007, what is the difference between the Aid flow from UN agencies (US$) in Middle East & North Africa (developing only) and Aid flow from UN agencies (US$) in Moldova?
Your answer should be compact. 6.46e+06. In the year 2007, what is the difference between the Aid flow from UN agencies (US$) of Gambia, The and Aid flow from UN agencies (US$) of Moldova?
Provide a short and direct response. -2.90e+05. What is the ratio of the Aid flow from UN agencies (US$) of Middle East & North Africa (developing only) in 2001 to that in 2002?
Give a very brief answer. 0.71. What is the ratio of the Aid flow from UN agencies (US$) in Albania in 2001 to that in 2002?
Your answer should be compact. 1.59. What is the ratio of the Aid flow from UN agencies (US$) of Gambia, The in 2001 to that in 2002?
Provide a succinct answer. 1.57. What is the ratio of the Aid flow from UN agencies (US$) in Moldova in 2001 to that in 2002?
Ensure brevity in your answer.  1.06. What is the ratio of the Aid flow from UN agencies (US$) in Middle East & North Africa (developing only) in 2001 to that in 2003?
Give a very brief answer. 1.01. What is the ratio of the Aid flow from UN agencies (US$) of Albania in 2001 to that in 2003?
Your answer should be compact. 2.01. What is the ratio of the Aid flow from UN agencies (US$) in Gambia, The in 2001 to that in 2003?
Provide a short and direct response. 0.87. What is the ratio of the Aid flow from UN agencies (US$) of Moldova in 2001 to that in 2003?
Offer a very short reply. 1.07. What is the ratio of the Aid flow from UN agencies (US$) of Middle East & North Africa (developing only) in 2001 to that in 2004?
Make the answer very short. 0.94. What is the ratio of the Aid flow from UN agencies (US$) of Albania in 2001 to that in 2004?
Provide a succinct answer. 3.95. What is the ratio of the Aid flow from UN agencies (US$) of Gambia, The in 2001 to that in 2004?
Ensure brevity in your answer.  0.98. What is the ratio of the Aid flow from UN agencies (US$) of Moldova in 2001 to that in 2004?
Keep it short and to the point. 1.22. What is the ratio of the Aid flow from UN agencies (US$) of Middle East & North Africa (developing only) in 2001 to that in 2005?
Offer a terse response. 2.84. What is the ratio of the Aid flow from UN agencies (US$) of Albania in 2001 to that in 2005?
Your response must be concise. 6.45. What is the ratio of the Aid flow from UN agencies (US$) of Gambia, The in 2001 to that in 2005?
Your response must be concise. 2.61. What is the ratio of the Aid flow from UN agencies (US$) of Moldova in 2001 to that in 2005?
Your response must be concise. 3.13. What is the ratio of the Aid flow from UN agencies (US$) of Middle East & North Africa (developing only) in 2001 to that in 2006?
Offer a very short reply. 3.06. What is the ratio of the Aid flow from UN agencies (US$) in Albania in 2001 to that in 2006?
Your response must be concise. 4.54. What is the ratio of the Aid flow from UN agencies (US$) in Gambia, The in 2001 to that in 2006?
Ensure brevity in your answer.  4.27. What is the ratio of the Aid flow from UN agencies (US$) of Moldova in 2001 to that in 2006?
Keep it short and to the point. 2.76. What is the ratio of the Aid flow from UN agencies (US$) in Middle East & North Africa (developing only) in 2001 to that in 2007?
Ensure brevity in your answer.  4.49. What is the ratio of the Aid flow from UN agencies (US$) in Albania in 2001 to that in 2007?
Ensure brevity in your answer.  4.45. What is the ratio of the Aid flow from UN agencies (US$) of Gambia, The in 2001 to that in 2007?
Ensure brevity in your answer.  3.92. What is the ratio of the Aid flow from UN agencies (US$) of Moldova in 2001 to that in 2007?
Make the answer very short. 2.29. What is the ratio of the Aid flow from UN agencies (US$) of Middle East & North Africa (developing only) in 2002 to that in 2003?
Your answer should be very brief. 1.42. What is the ratio of the Aid flow from UN agencies (US$) in Albania in 2002 to that in 2003?
Ensure brevity in your answer.  1.26. What is the ratio of the Aid flow from UN agencies (US$) in Gambia, The in 2002 to that in 2003?
Make the answer very short. 0.56. What is the ratio of the Aid flow from UN agencies (US$) of Moldova in 2002 to that in 2003?
Keep it short and to the point. 1.01. What is the ratio of the Aid flow from UN agencies (US$) in Middle East & North Africa (developing only) in 2002 to that in 2004?
Keep it short and to the point. 1.31. What is the ratio of the Aid flow from UN agencies (US$) in Albania in 2002 to that in 2004?
Ensure brevity in your answer.  2.48. What is the ratio of the Aid flow from UN agencies (US$) in Gambia, The in 2002 to that in 2004?
Make the answer very short. 0.62. What is the ratio of the Aid flow from UN agencies (US$) of Moldova in 2002 to that in 2004?
Keep it short and to the point. 1.16. What is the ratio of the Aid flow from UN agencies (US$) in Middle East & North Africa (developing only) in 2002 to that in 2005?
Offer a terse response. 3.98. What is the ratio of the Aid flow from UN agencies (US$) in Albania in 2002 to that in 2005?
Your answer should be very brief. 4.05. What is the ratio of the Aid flow from UN agencies (US$) in Gambia, The in 2002 to that in 2005?
Make the answer very short. 1.67. What is the ratio of the Aid flow from UN agencies (US$) in Moldova in 2002 to that in 2005?
Ensure brevity in your answer.  2.97. What is the ratio of the Aid flow from UN agencies (US$) of Middle East & North Africa (developing only) in 2002 to that in 2006?
Offer a terse response. 4.29. What is the ratio of the Aid flow from UN agencies (US$) of Albania in 2002 to that in 2006?
Your answer should be compact. 2.85. What is the ratio of the Aid flow from UN agencies (US$) of Gambia, The in 2002 to that in 2006?
Offer a very short reply. 2.73. What is the ratio of the Aid flow from UN agencies (US$) of Moldova in 2002 to that in 2006?
Your answer should be compact. 2.62. What is the ratio of the Aid flow from UN agencies (US$) of Middle East & North Africa (developing only) in 2002 to that in 2007?
Offer a very short reply. 6.3. What is the ratio of the Aid flow from UN agencies (US$) in Albania in 2002 to that in 2007?
Offer a terse response. 2.8. What is the ratio of the Aid flow from UN agencies (US$) in Gambia, The in 2002 to that in 2007?
Make the answer very short. 2.5. What is the ratio of the Aid flow from UN agencies (US$) of Moldova in 2002 to that in 2007?
Your answer should be very brief. 2.17. What is the ratio of the Aid flow from UN agencies (US$) of Middle East & North Africa (developing only) in 2003 to that in 2004?
Ensure brevity in your answer.  0.92. What is the ratio of the Aid flow from UN agencies (US$) of Albania in 2003 to that in 2004?
Provide a short and direct response. 1.97. What is the ratio of the Aid flow from UN agencies (US$) in Moldova in 2003 to that in 2004?
Provide a short and direct response. 1.14. What is the ratio of the Aid flow from UN agencies (US$) of Middle East & North Africa (developing only) in 2003 to that in 2005?
Ensure brevity in your answer.  2.8. What is the ratio of the Aid flow from UN agencies (US$) in Albania in 2003 to that in 2005?
Ensure brevity in your answer.  3.21. What is the ratio of the Aid flow from UN agencies (US$) in Gambia, The in 2003 to that in 2005?
Ensure brevity in your answer.  3. What is the ratio of the Aid flow from UN agencies (US$) of Moldova in 2003 to that in 2005?
Keep it short and to the point. 2.93. What is the ratio of the Aid flow from UN agencies (US$) in Middle East & North Africa (developing only) in 2003 to that in 2006?
Provide a short and direct response. 3.02. What is the ratio of the Aid flow from UN agencies (US$) of Albania in 2003 to that in 2006?
Offer a terse response. 2.26. What is the ratio of the Aid flow from UN agencies (US$) of Gambia, The in 2003 to that in 2006?
Provide a short and direct response. 4.91. What is the ratio of the Aid flow from UN agencies (US$) of Moldova in 2003 to that in 2006?
Offer a very short reply. 2.59. What is the ratio of the Aid flow from UN agencies (US$) of Middle East & North Africa (developing only) in 2003 to that in 2007?
Provide a short and direct response. 4.44. What is the ratio of the Aid flow from UN agencies (US$) of Albania in 2003 to that in 2007?
Make the answer very short. 2.22. What is the ratio of the Aid flow from UN agencies (US$) of Gambia, The in 2003 to that in 2007?
Your answer should be compact. 4.5. What is the ratio of the Aid flow from UN agencies (US$) of Moldova in 2003 to that in 2007?
Make the answer very short. 2.15. What is the ratio of the Aid flow from UN agencies (US$) of Middle East & North Africa (developing only) in 2004 to that in 2005?
Your answer should be very brief. 3.04. What is the ratio of the Aid flow from UN agencies (US$) of Albania in 2004 to that in 2005?
Ensure brevity in your answer.  1.63. What is the ratio of the Aid flow from UN agencies (US$) of Gambia, The in 2004 to that in 2005?
Ensure brevity in your answer.  2.67. What is the ratio of the Aid flow from UN agencies (US$) of Moldova in 2004 to that in 2005?
Offer a terse response. 2.57. What is the ratio of the Aid flow from UN agencies (US$) in Middle East & North Africa (developing only) in 2004 to that in 2006?
Keep it short and to the point. 3.27. What is the ratio of the Aid flow from UN agencies (US$) in Albania in 2004 to that in 2006?
Keep it short and to the point. 1.15. What is the ratio of the Aid flow from UN agencies (US$) in Gambia, The in 2004 to that in 2006?
Ensure brevity in your answer.  4.36. What is the ratio of the Aid flow from UN agencies (US$) of Moldova in 2004 to that in 2006?
Your response must be concise. 2.26. What is the ratio of the Aid flow from UN agencies (US$) in Middle East & North Africa (developing only) in 2004 to that in 2007?
Offer a very short reply. 4.8. What is the ratio of the Aid flow from UN agencies (US$) of Albania in 2004 to that in 2007?
Provide a succinct answer. 1.13. What is the ratio of the Aid flow from UN agencies (US$) of Gambia, The in 2004 to that in 2007?
Your answer should be compact. 4. What is the ratio of the Aid flow from UN agencies (US$) in Moldova in 2004 to that in 2007?
Your answer should be compact. 1.88. What is the ratio of the Aid flow from UN agencies (US$) of Middle East & North Africa (developing only) in 2005 to that in 2006?
Offer a very short reply. 1.08. What is the ratio of the Aid flow from UN agencies (US$) of Albania in 2005 to that in 2006?
Your answer should be very brief. 0.7. What is the ratio of the Aid flow from UN agencies (US$) in Gambia, The in 2005 to that in 2006?
Your answer should be compact. 1.64. What is the ratio of the Aid flow from UN agencies (US$) of Moldova in 2005 to that in 2006?
Make the answer very short. 0.88. What is the ratio of the Aid flow from UN agencies (US$) of Middle East & North Africa (developing only) in 2005 to that in 2007?
Provide a short and direct response. 1.58. What is the ratio of the Aid flow from UN agencies (US$) in Albania in 2005 to that in 2007?
Keep it short and to the point. 0.69. What is the ratio of the Aid flow from UN agencies (US$) in Gambia, The in 2005 to that in 2007?
Keep it short and to the point. 1.5. What is the ratio of the Aid flow from UN agencies (US$) in Moldova in 2005 to that in 2007?
Your response must be concise. 0.73. What is the ratio of the Aid flow from UN agencies (US$) in Middle East & North Africa (developing only) in 2006 to that in 2007?
Keep it short and to the point. 1.47. What is the ratio of the Aid flow from UN agencies (US$) in Albania in 2006 to that in 2007?
Offer a very short reply. 0.98. What is the ratio of the Aid flow from UN agencies (US$) in Gambia, The in 2006 to that in 2007?
Ensure brevity in your answer.  0.92. What is the ratio of the Aid flow from UN agencies (US$) in Moldova in 2006 to that in 2007?
Provide a succinct answer. 0.83. What is the difference between the highest and the second highest Aid flow from UN agencies (US$) of Middle East & North Africa (developing only)?
Provide a short and direct response. 1.03e+07. What is the difference between the highest and the second highest Aid flow from UN agencies (US$) in Albania?
Offer a terse response. 9.10e+05. What is the difference between the highest and the lowest Aid flow from UN agencies (US$) of Middle East & North Africa (developing only)?
Keep it short and to the point. 3.64e+07. What is the difference between the highest and the lowest Aid flow from UN agencies (US$) of Albania?
Make the answer very short. 2.07e+06. What is the difference between the highest and the lowest Aid flow from UN agencies (US$) of Gambia, The?
Ensure brevity in your answer.  4.30e+05. What is the difference between the highest and the lowest Aid flow from UN agencies (US$) in Moldova?
Offer a very short reply. 6.40e+05. 